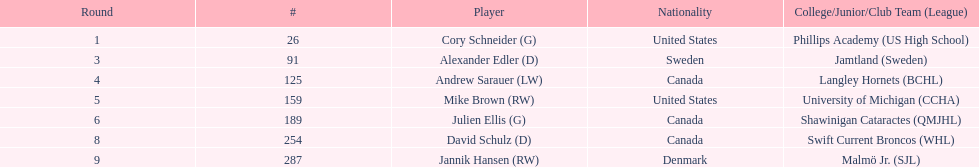What is the number of canadian players listed? 3. 